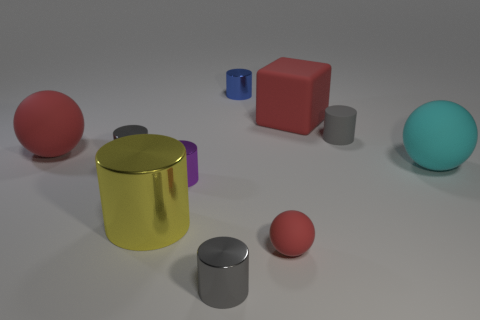There is a gray object to the right of the gray shiny object that is in front of the red ball in front of the big cyan rubber object; what is its shape?
Your response must be concise. Cylinder. Is the number of gray shiny cylinders in front of the cyan thing greater than the number of tiny matte things?
Give a very brief answer. No. There is a small red object; is its shape the same as the small metallic object that is behind the red matte block?
Make the answer very short. No. There is a gray cylinder behind the rubber sphere left of the purple shiny object; what number of big red rubber objects are in front of it?
Provide a succinct answer. 1. The other sphere that is the same size as the cyan rubber ball is what color?
Ensure brevity in your answer.  Red. There is a yellow shiny cylinder right of the gray cylinder that is left of the yellow thing; what size is it?
Offer a terse response. Large. What is the size of the cube that is the same color as the tiny matte sphere?
Provide a succinct answer. Large. How many other things are there of the same size as the cyan rubber thing?
Your response must be concise. 3. What number of yellow things are there?
Your response must be concise. 1. Does the blue metal cylinder have the same size as the cube?
Keep it short and to the point. No. 